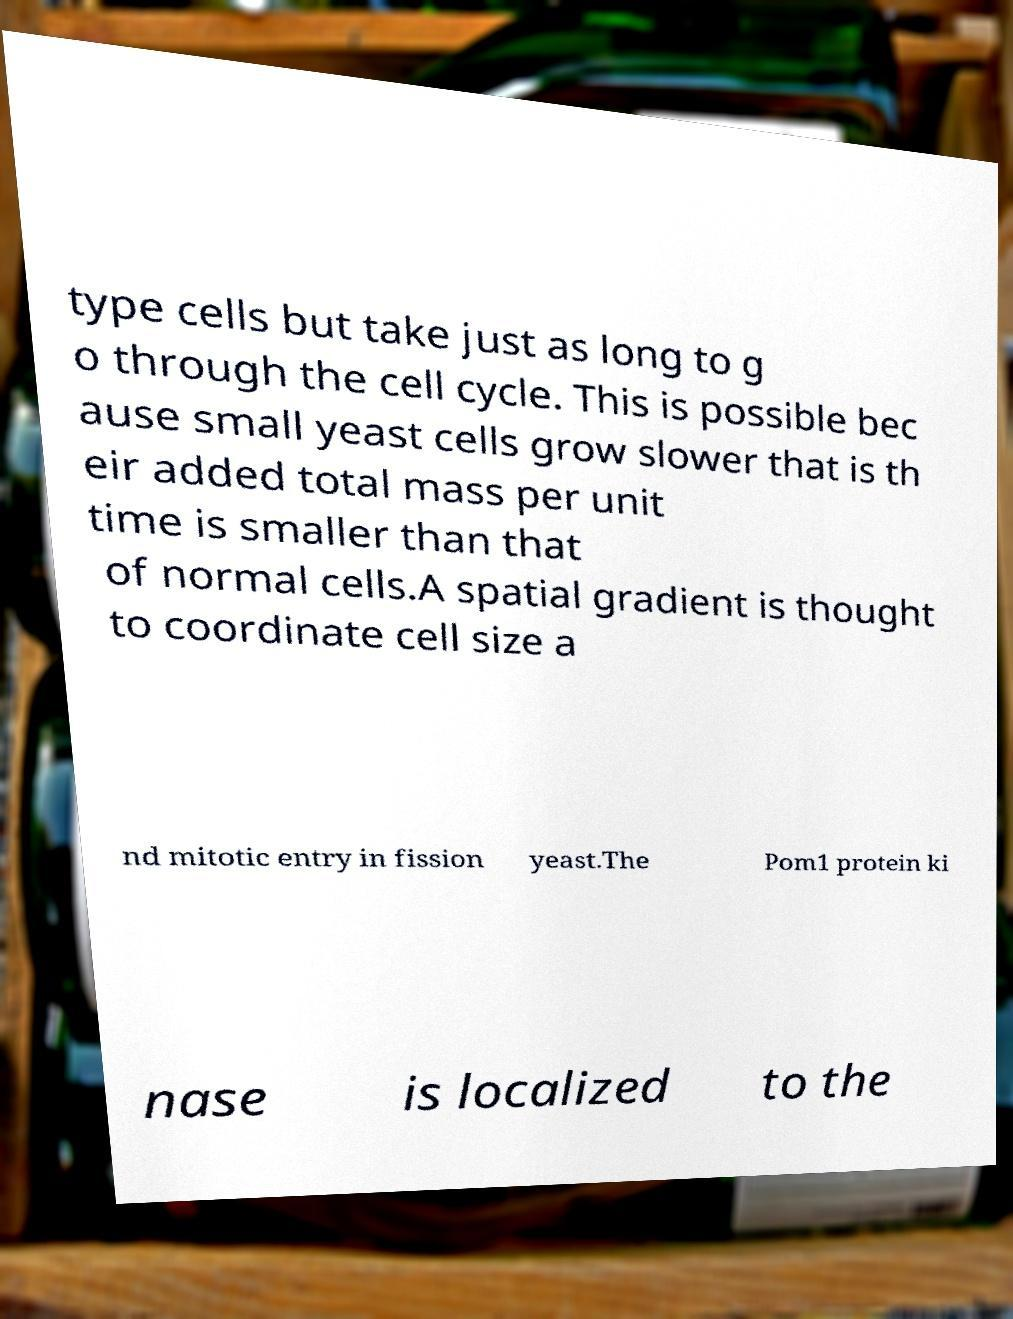Could you assist in decoding the text presented in this image and type it out clearly? type cells but take just as long to g o through the cell cycle. This is possible bec ause small yeast cells grow slower that is th eir added total mass per unit time is smaller than that of normal cells.A spatial gradient is thought to coordinate cell size a nd mitotic entry in fission yeast.The Pom1 protein ki nase is localized to the 